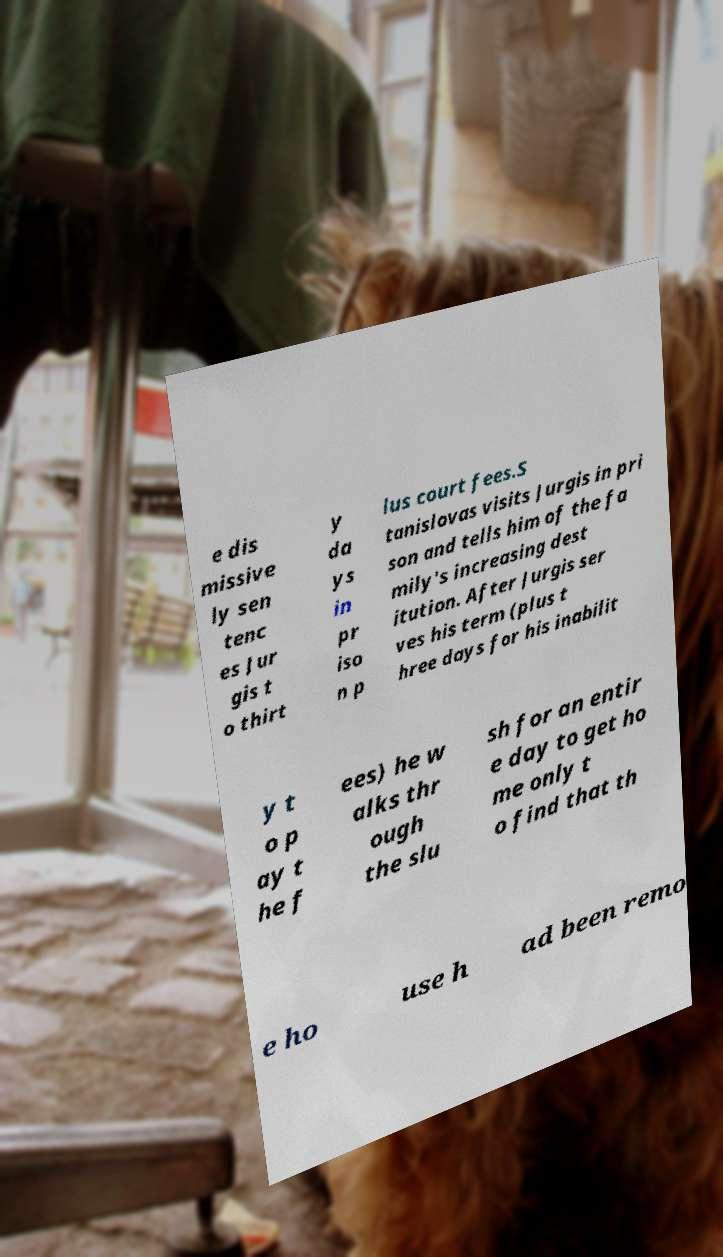Could you extract and type out the text from this image? e dis missive ly sen tenc es Jur gis t o thirt y da ys in pr iso n p lus court fees.S tanislovas visits Jurgis in pri son and tells him of the fa mily's increasing dest itution. After Jurgis ser ves his term (plus t hree days for his inabilit y t o p ay t he f ees) he w alks thr ough the slu sh for an entir e day to get ho me only t o find that th e ho use h ad been remo 